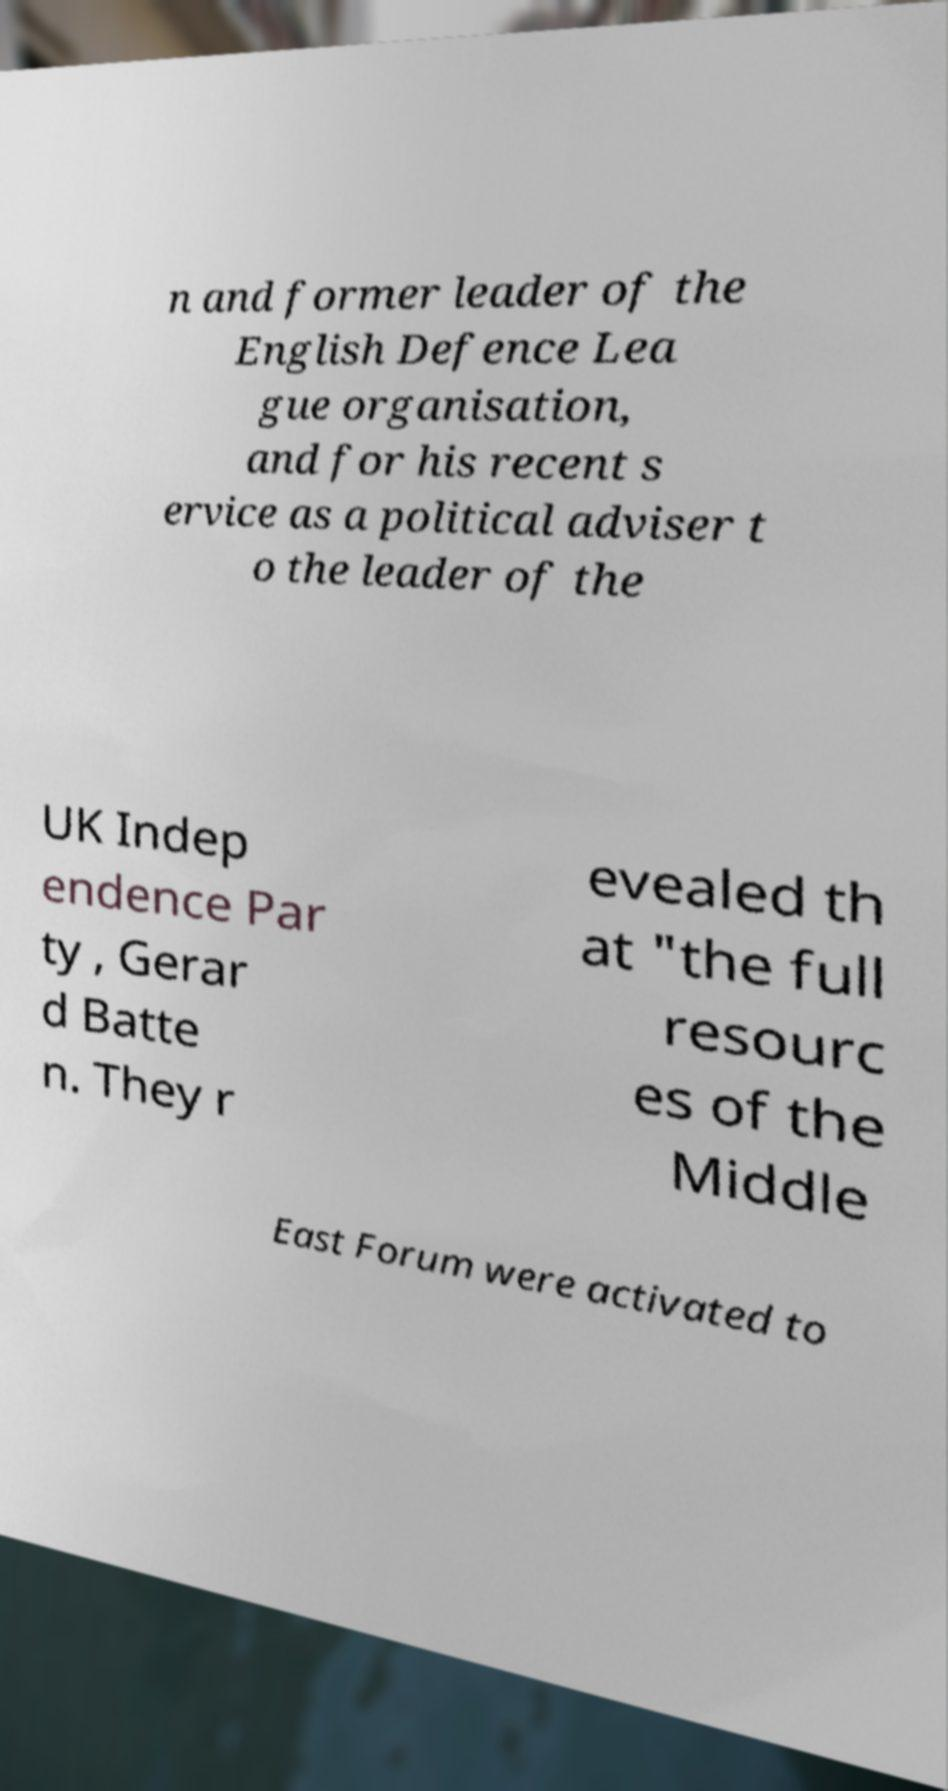Please identify and transcribe the text found in this image. n and former leader of the English Defence Lea gue organisation, and for his recent s ervice as a political adviser t o the leader of the UK Indep endence Par ty , Gerar d Batte n. They r evealed th at "the full resourc es of the Middle East Forum were activated to 